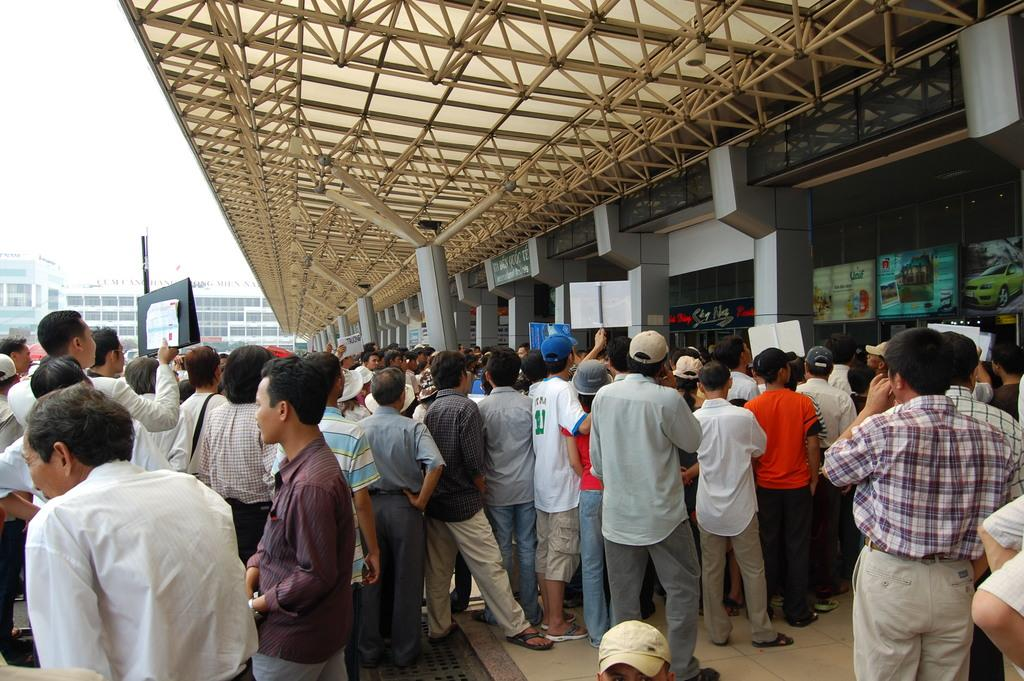What is the main subject of the image? The main subject of the image is a group of people standing in the middle of the image. Can you describe the location of the building in the image? There is a building on the right side of the image. What type of volcano can be seen erupting in the background of the image? There is no volcano present in the image; it only features a group of people and a building. How many women are present in the image? The provided facts do not specify the gender of the people in the image, so we cannot determine the number of women. 